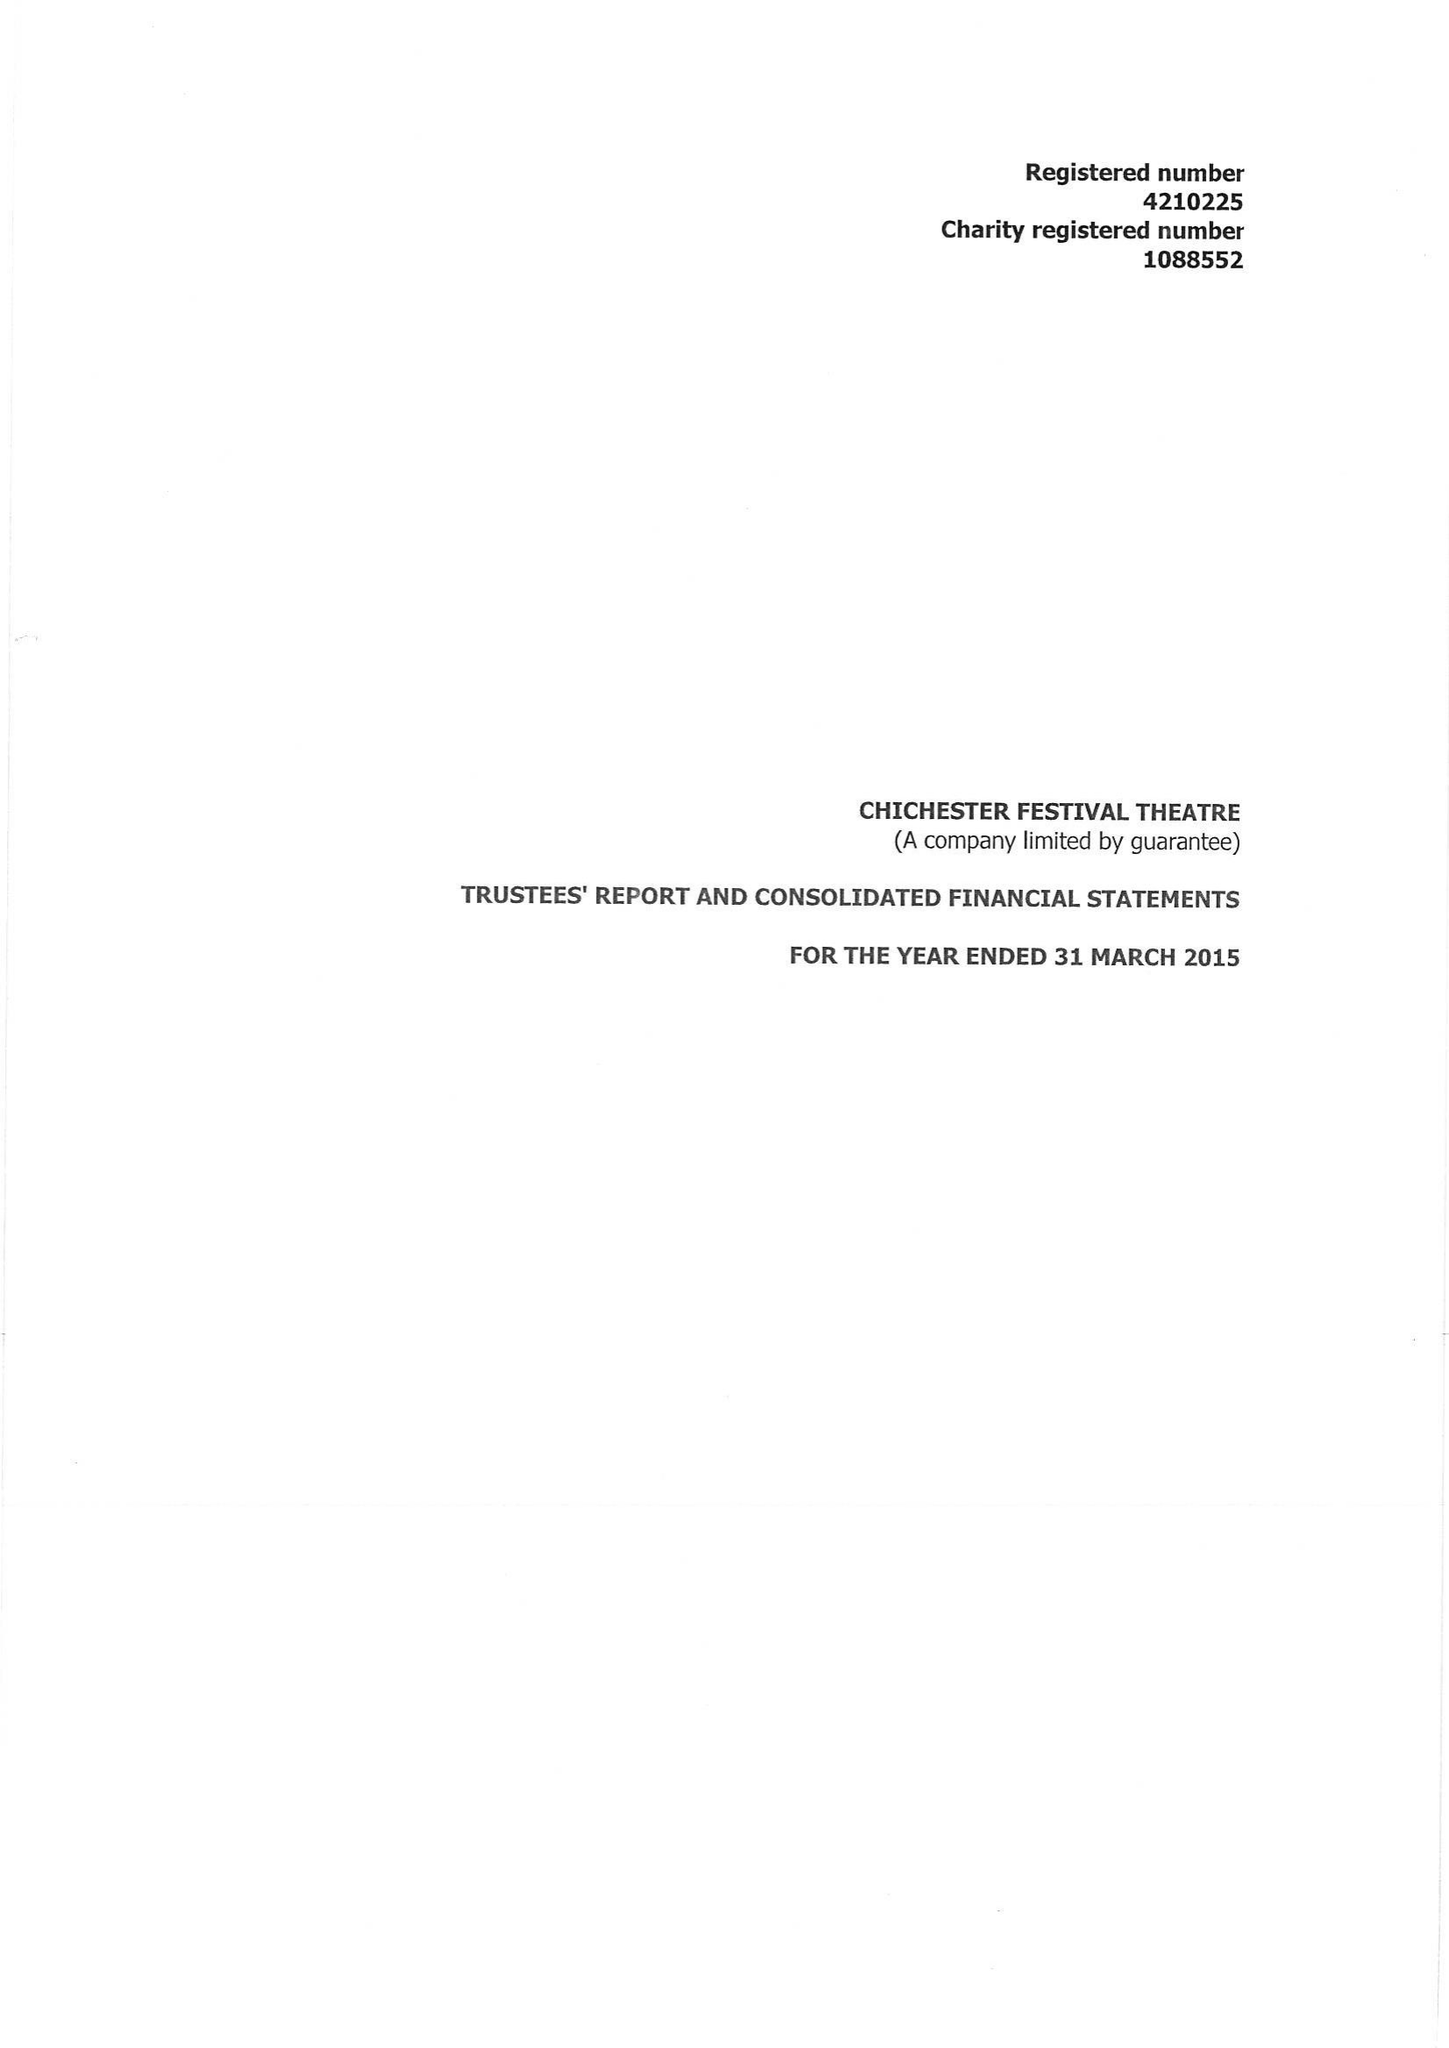What is the value for the address__post_town?
Answer the question using a single word or phrase. CHICHESTER 